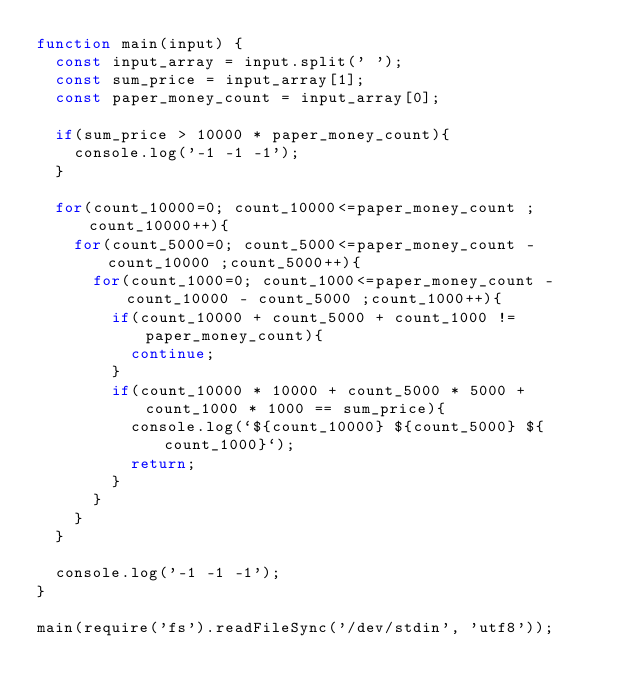Convert code to text. <code><loc_0><loc_0><loc_500><loc_500><_JavaScript_>function main(input) {
  const input_array = input.split(' ');
  const sum_price = input_array[1];
  const paper_money_count = input_array[0];
  
  if(sum_price > 10000 * paper_money_count){
    console.log('-1 -1 -1');
  }

  for(count_10000=0; count_10000<=paper_money_count ;count_10000++){
    for(count_5000=0; count_5000<=paper_money_count - count_10000 ;count_5000++){
      for(count_1000=0; count_1000<=paper_money_count - count_10000 - count_5000 ;count_1000++){
        if(count_10000 + count_5000 + count_1000 != paper_money_count){
          continue;
        }
        if(count_10000 * 10000 + count_5000 * 5000 + count_1000 * 1000 == sum_price){
          console.log(`${count_10000} ${count_5000} ${count_1000}`);
          return;
        }
      }
    }
  }

  console.log('-1 -1 -1');
}
 
main(require('fs').readFileSync('/dev/stdin', 'utf8'));
</code> 